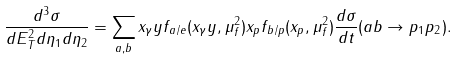<formula> <loc_0><loc_0><loc_500><loc_500>\frac { d ^ { 3 } \sigma } { d E _ { T } ^ { 2 } d \eta _ { 1 } d \eta _ { 2 } } = \sum _ { a , b } x _ { \gamma } y f _ { a / e } ( x _ { \gamma } y , \mu _ { f } ^ { 2 } ) x _ { p } f _ { b / p } ( x _ { p } , \mu _ { f } ^ { 2 } ) \frac { d \sigma } { d t } ( a b \rightarrow p _ { 1 } p _ { 2 } ) .</formula> 